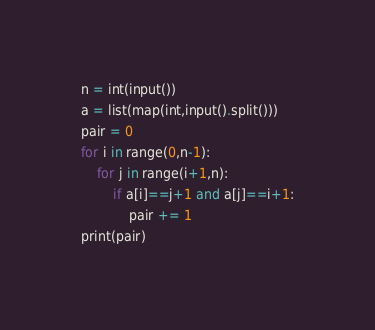Convert code to text. <code><loc_0><loc_0><loc_500><loc_500><_Python_>n = int(input())
a = list(map(int,input().split()))
pair = 0
for i in range(0,n-1):
    for j in range(i+1,n):
        if a[i]==j+1 and a[j]==i+1:
            pair += 1
print(pair)</code> 